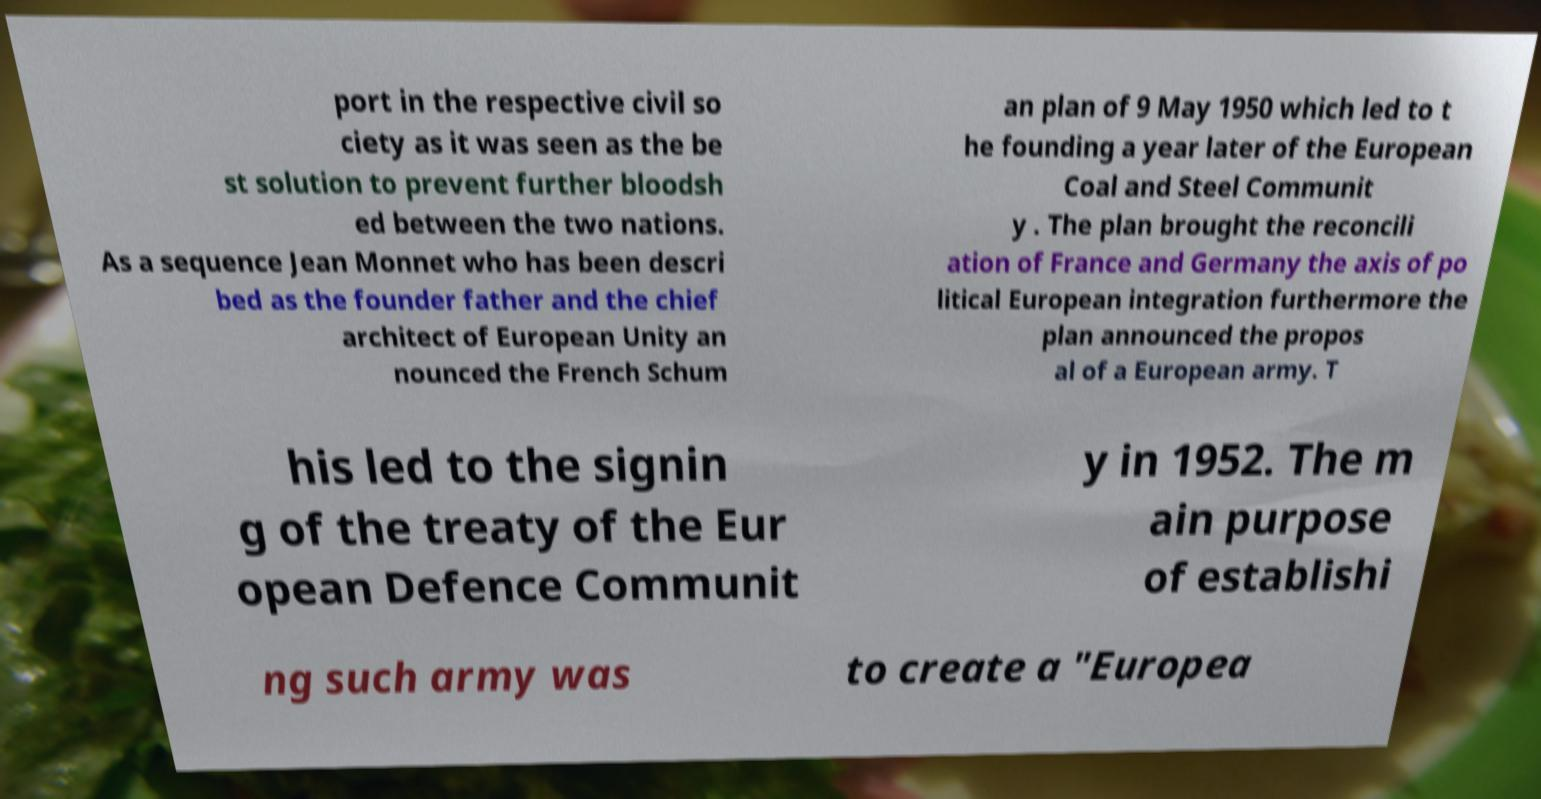There's text embedded in this image that I need extracted. Can you transcribe it verbatim? port in the respective civil so ciety as it was seen as the be st solution to prevent further bloodsh ed between the two nations. As a sequence Jean Monnet who has been descri bed as the founder father and the chief architect of European Unity an nounced the French Schum an plan of 9 May 1950 which led to t he founding a year later of the European Coal and Steel Communit y . The plan brought the reconcili ation of France and Germany the axis of po litical European integration furthermore the plan announced the propos al of a European army. T his led to the signin g of the treaty of the Eur opean Defence Communit y in 1952. The m ain purpose of establishi ng such army was to create a "Europea 